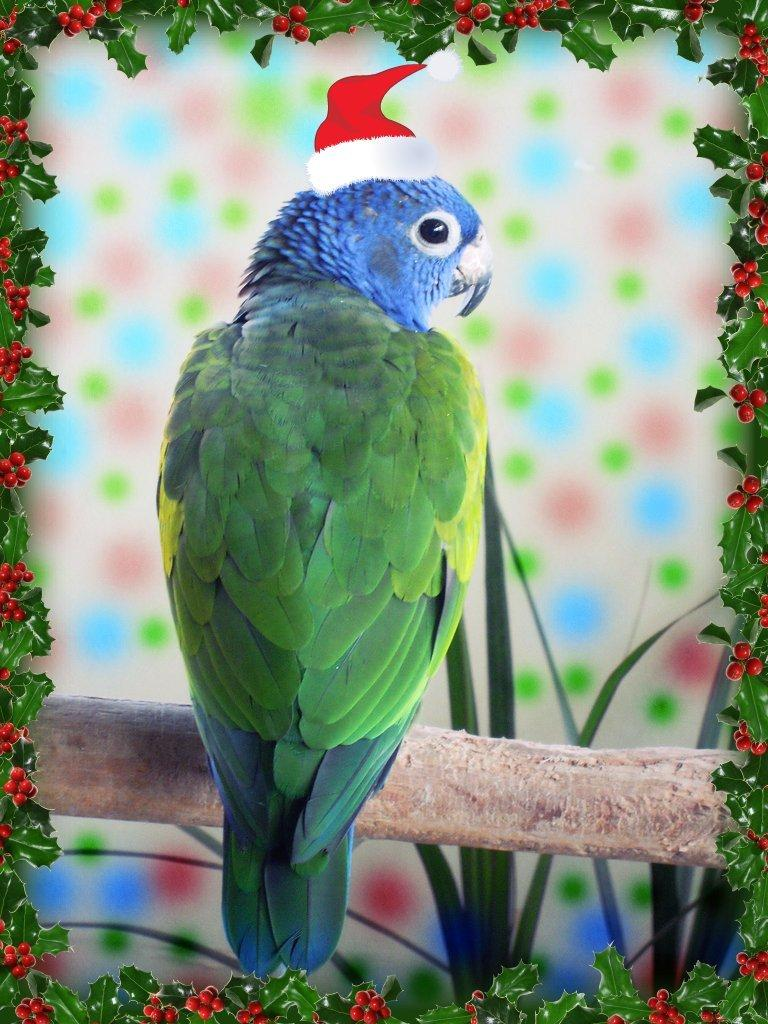What type of animal is in the image? There is a parrot in the image. What is unusual about the parrot's appearance? There is a Christmas tree on the head of the parrot. What type of vegetation is present in the image? Leaves are present in the image. What type of fruit is present in the image? Cherries are present in the image. How does the parrot say good-bye in the image? The image does not show the parrot saying good-bye or making any sounds. 